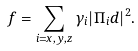<formula> <loc_0><loc_0><loc_500><loc_500>f = \sum _ { i = x , y , z } \gamma _ { i } | \Pi _ { i } d | ^ { 2 } .</formula> 